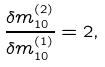Convert formula to latex. <formula><loc_0><loc_0><loc_500><loc_500>\frac { \delta m _ { 1 0 } ^ { ( 2 ) } } { \delta m _ { 1 0 } ^ { ( 1 ) } } = 2 ,</formula> 